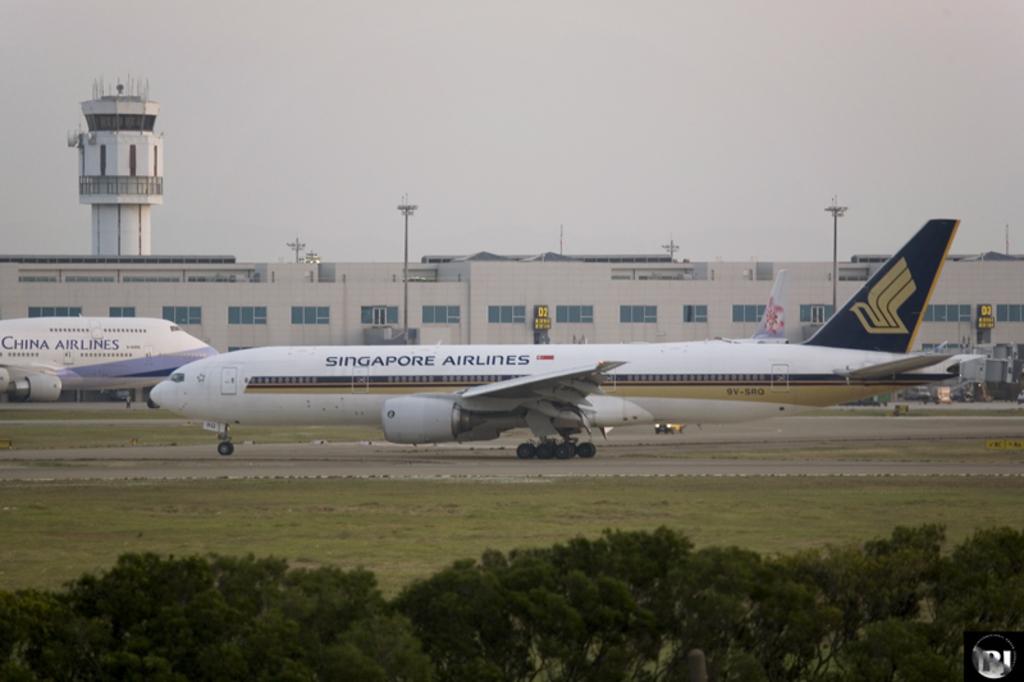Which airline is theat plane for?
Keep it short and to the point. Singapore. What airlines takes up most of the photo?
Give a very brief answer. Singapore airlines. 